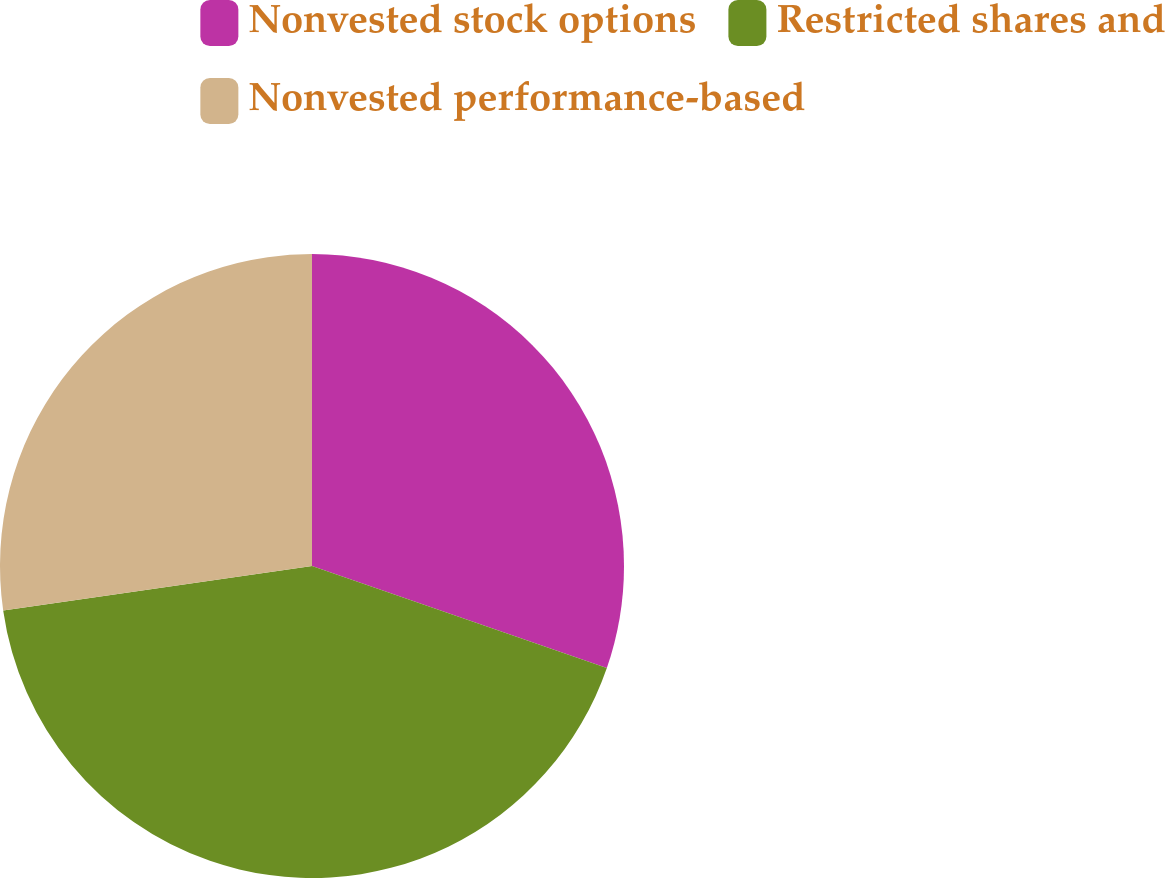Convert chart. <chart><loc_0><loc_0><loc_500><loc_500><pie_chart><fcel>Nonvested stock options<fcel>Restricted shares and<fcel>Nonvested performance-based<nl><fcel>30.3%<fcel>42.42%<fcel>27.27%<nl></chart> 